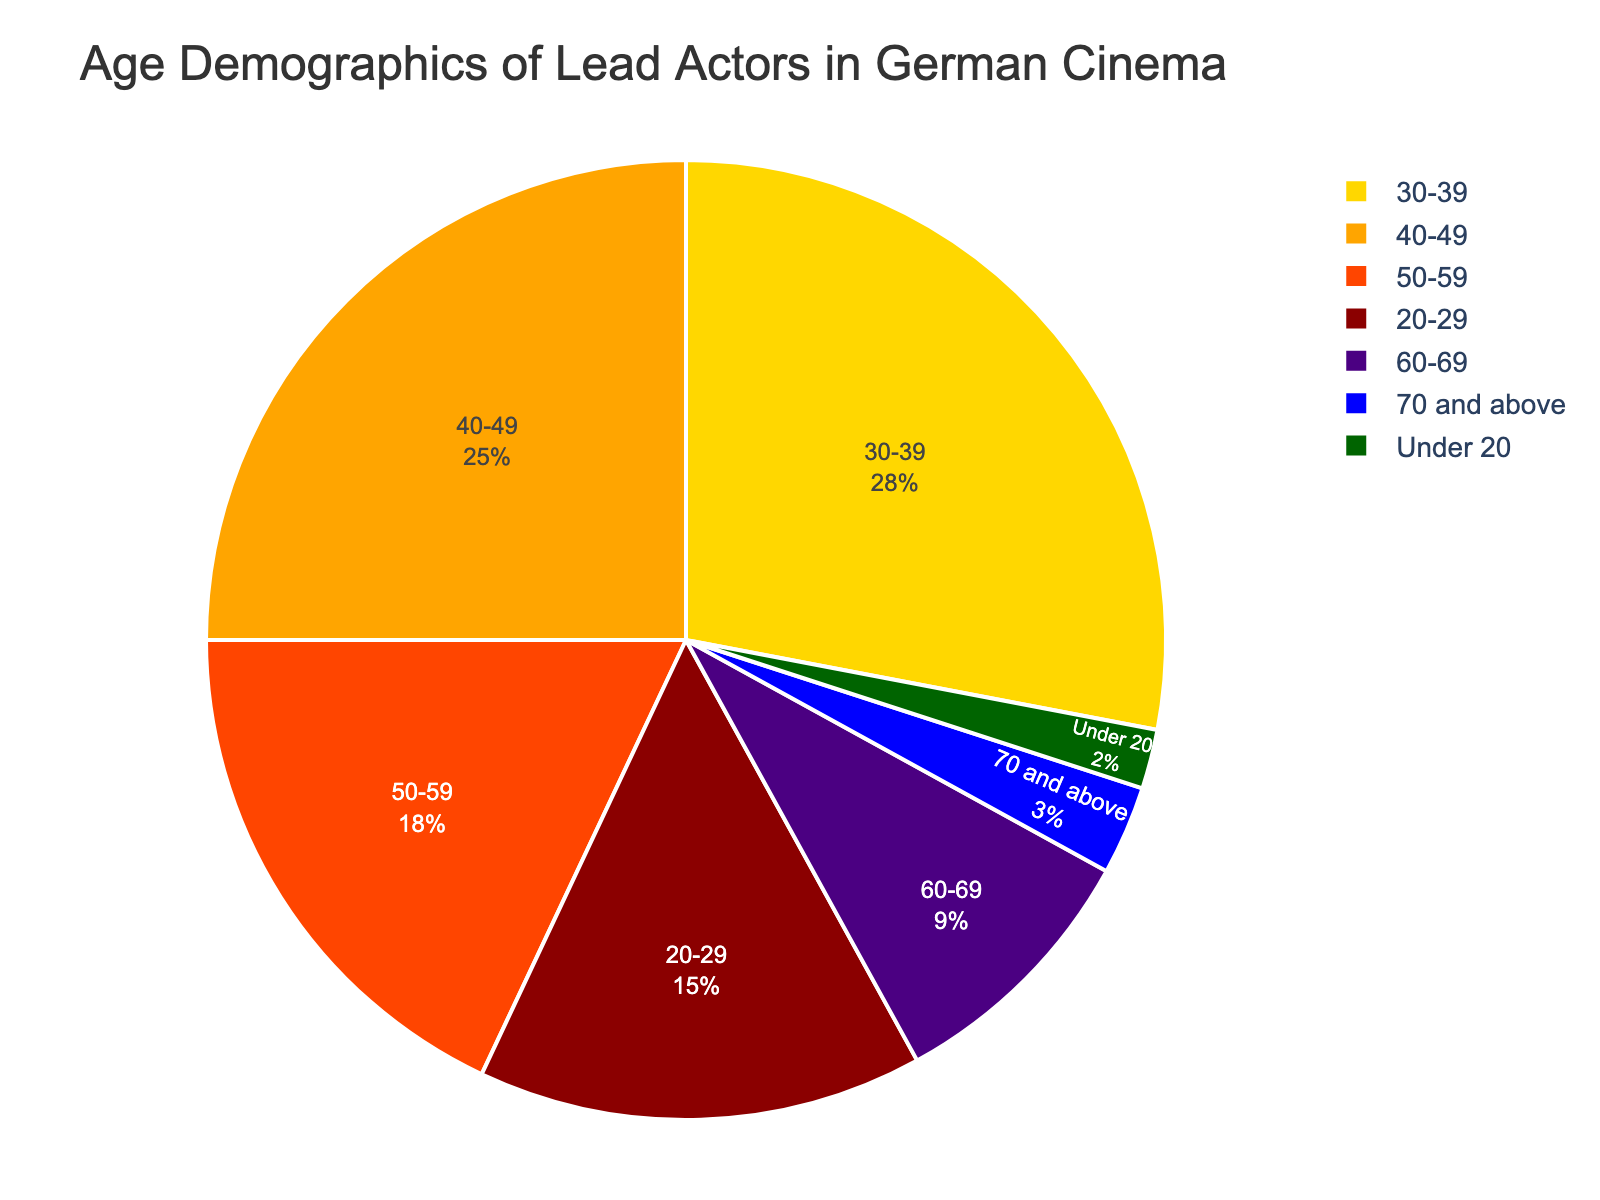What's the largest age group of lead actors in German cinema? Referring to the pie chart, the age group with the highest percentage is 30-39 with 28%.
Answer: 30-39 Which age group has the smallest representation among lead actors in German cinema? The smallest wedge in the pie chart is the 'Under 20' age group with 2%.
Answer: Under 20 How much more percentage do actors aged 30-39 represent compared to those aged 60-69? The pie chart shows 30-39 age group at 28% and 60-69 age group at 9%. The difference is calculated as 28% - 9% = 19%.
Answer: 19% What is the combined percentage of lead actors aged 20-29 and 40-49? The pie chart shows 20-29 age group at 15% and 40-49 age group at 25%. Adding these together: 15% + 25% = 40%.
Answer: 40% Which age group appears in gold color on the pie chart? Examining the pie chart, the 'Under 20' age group is represented by the gold color.
Answer: Under 20 Is the percentage of lead actors aged 50-59 greater than the combined percentage of those under 20 and those 70 and above? The pie chart shows 50-59 age group at 18%, Under 20 at 2%, and 70 and above at 3%. Adding Under 20 and 70 and above: 2% + 3% = 5%, which is less than 18%.
Answer: Yes What's the difference in percentage points between the 50-59 age group and the 60-69 age group? According to the pie chart, the 50-59 age group is 18% and the 60-69 age group is 9%. The difference is 18% - 9% = 9%.
Answer: 9% Which age group has a higher percentage: 40-49 or 50-59? From the pie chart, the 40-49 age group has a percentage of 25%, while the 50-59 age group has a percentage of 18%. Since 25% > 18%, the 40-49 age group is higher.
Answer: 40-49 By how much does the percentage of actors aged 40-49 exceed those aged 60-69? The pie chart shows that the percentage for the 40-49 age group is 25%, and for the 60-69 age group, it's 9%. The difference is 25% - 9% = 16%.
Answer: 16% What is the total percentage of lead actors aged 50 and above? The pie chart shows percentages for the 50-59 (18%), 60-69 (9%), and 70 and above (3%) age groups. Adding them together: 18% + 9% + 3% = 30%.
Answer: 30% 